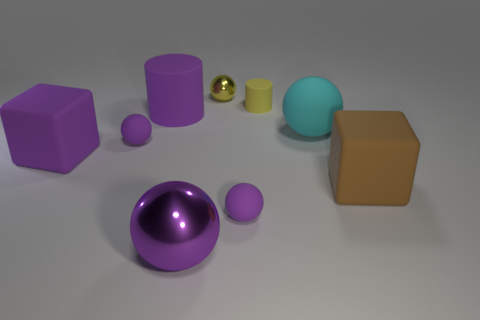Subtract all tiny balls. How many balls are left? 2 Subtract all cyan balls. How many balls are left? 4 Subtract all purple cylinders. Subtract all red cubes. How many cylinders are left? 1 Subtract all purple cylinders. How many yellow spheres are left? 1 Subtract all cyan matte things. Subtract all big brown rubber blocks. How many objects are left? 7 Add 7 small metallic balls. How many small metallic balls are left? 8 Add 7 tiny yellow rubber cylinders. How many tiny yellow rubber cylinders exist? 8 Subtract 0 yellow blocks. How many objects are left? 9 Subtract all spheres. How many objects are left? 4 Subtract 1 blocks. How many blocks are left? 1 